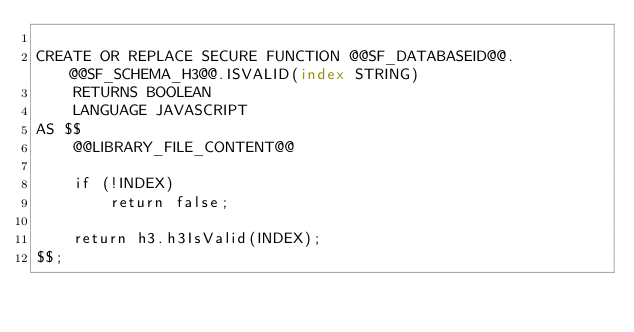Convert code to text. <code><loc_0><loc_0><loc_500><loc_500><_SQL_>
CREATE OR REPLACE SECURE FUNCTION @@SF_DATABASEID@@.@@SF_SCHEMA_H3@@.ISVALID(index STRING)
    RETURNS BOOLEAN
    LANGUAGE JAVASCRIPT
AS $$
    @@LIBRARY_FILE_CONTENT@@

    if (!INDEX)
        return false;

    return h3.h3IsValid(INDEX);
$$;
</code> 